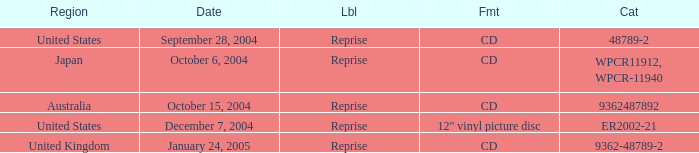Name the catalogue for australia 9362487892.0. 